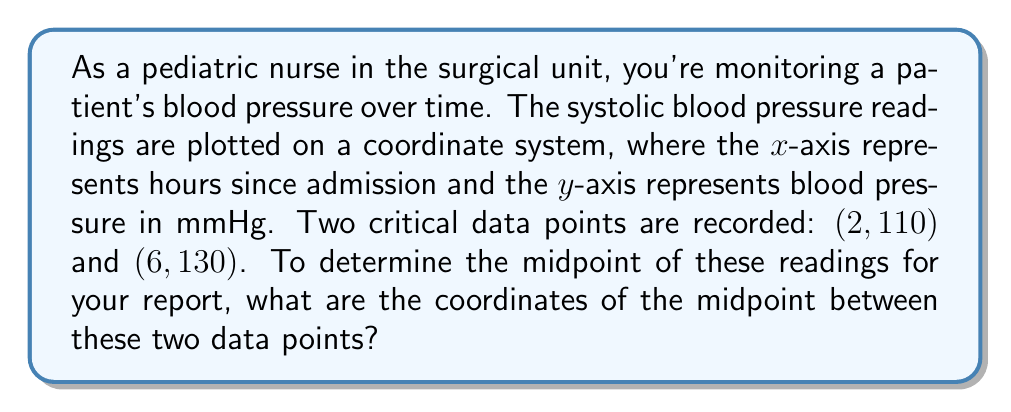Solve this math problem. To find the midpoint between two points in a coordinate system, we use the midpoint formula:

$$ \text{Midpoint} = \left(\frac{x_1 + x_2}{2}, \frac{y_1 + y_2}{2}\right) $$

Where $(x_1, y_1)$ is the first point and $(x_2, y_2)$ is the second point.

Given:
- Point 1: $(2, 110)$, so $x_1 = 2$ and $y_1 = 110$
- Point 2: $(6, 130)$, so $x_2 = 6$ and $y_2 = 130$

Let's calculate the x-coordinate of the midpoint:

$$ x_{\text{midpoint}} = \frac{x_1 + x_2}{2} = \frac{2 + 6}{2} = \frac{8}{2} = 4 $$

Now, let's calculate the y-coordinate of the midpoint:

$$ y_{\text{midpoint}} = \frac{y_1 + y_2}{2} = \frac{110 + 130}{2} = \frac{240}{2} = 120 $$

Therefore, the midpoint coordinates are $(4, 120)$.

Interpreting this result in the context of the patient data:
- The midpoint occurs 4 hours after admission
- The blood pressure at this midpoint is 120 mmHg
Answer: The coordinates of the midpoint are $(4, 120)$. 